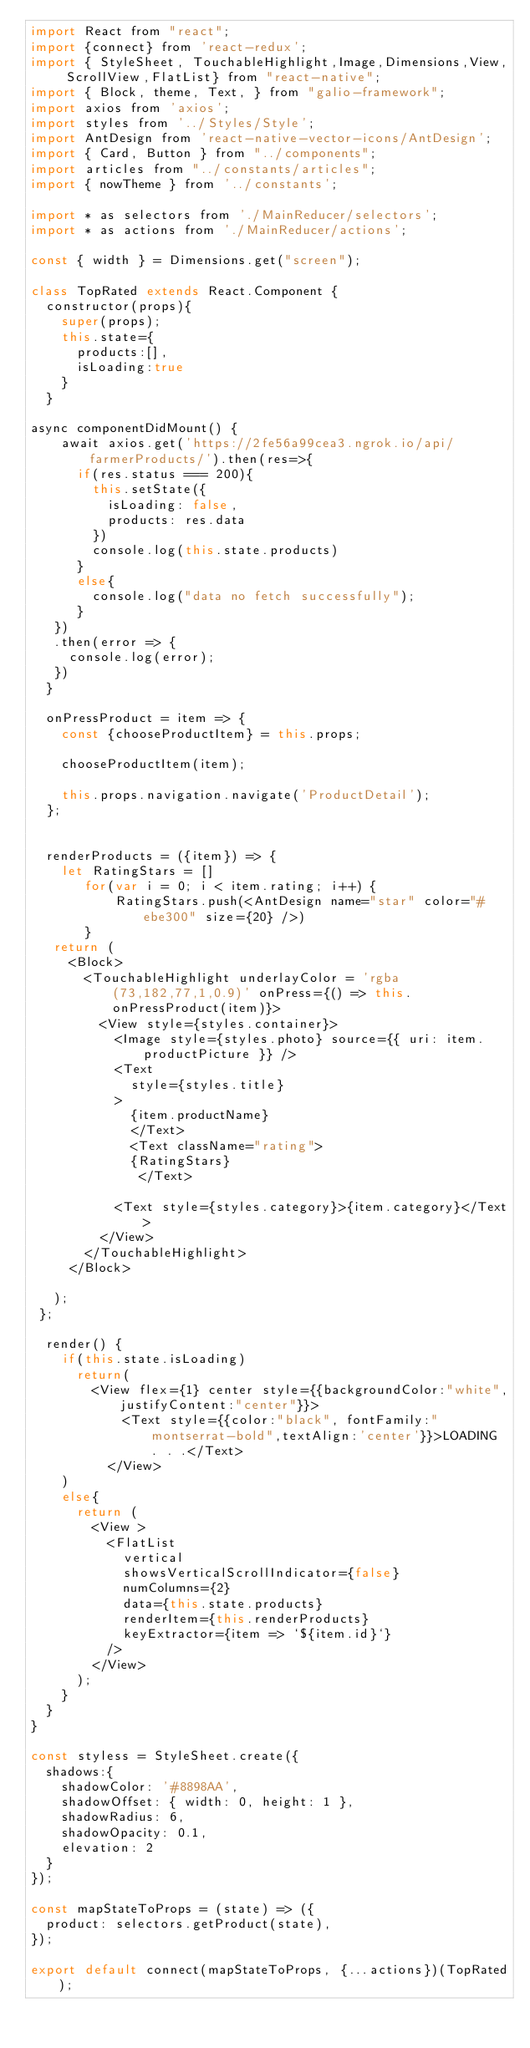<code> <loc_0><loc_0><loc_500><loc_500><_JavaScript_>import React from "react";
import {connect} from 'react-redux';
import { StyleSheet, TouchableHighlight,Image,Dimensions,View, ScrollView,FlatList} from "react-native";
import { Block, theme, Text, } from "galio-framework";
import axios from 'axios';
import styles from '../Styles/Style';
import AntDesign from 'react-native-vector-icons/AntDesign';
import { Card, Button } from "../components";
import articles from "../constants/articles";
import { nowTheme } from '../constants';

import * as selectors from './MainReducer/selectors';
import * as actions from './MainReducer/actions'; 

const { width } = Dimensions.get("screen");

class TopRated extends React.Component {
  constructor(props){
    super(props);
    this.state={
      products:[],
      isLoading:true
    }
  }

async componentDidMount() {    
    await axios.get('https://2fe56a99cea3.ngrok.io/api/farmerProducts/').then(res=>{
      if(res.status === 200){
        this.setState({
          isLoading: false,
          products: res.data 
        })
        console.log(this.state.products)
      }
      else{
        console.log("data no fetch successfully");
      }
   })
   .then(error => {
     console.log(error);
   })
  }
  
  onPressProduct = item => {
    const {chooseProductItem} = this.props;

    chooseProductItem(item);

    this.props.navigation.navigate('ProductDetail');
  };


  renderProducts = ({item}) => {
    let RatingStars = []
       for(var i = 0; i < item.rating; i++) {
           RatingStars.push(<AntDesign name="star" color="#ebe300" size={20} />)
       }
   return (
     <Block>
       <TouchableHighlight underlayColor = 'rgba(73,182,77,1,0.9)' onPress={() => this.onPressProduct(item)}>
         <View style={styles.container}>
           <Image style={styles.photo} source={{ uri: item.productPicture }} />
           <Text 
             style={styles.title}
           >
             {item.productName}
             </Text>
             <Text className="rating">
             {RatingStars}
              </Text>  
                
           <Text style={styles.category}>{item.category}</Text>
         </View>
       </TouchableHighlight>  
     </Block>      
     
   );
 };

  render() {
    if(this.state.isLoading) 
      return(
        <View flex={1} center style={{backgroundColor:"white",justifyContent:"center"}}>
            <Text style={{color:"black", fontFamily:"montserrat-bold",textAlign:'center'}}>LOADING . . .</Text>
          </View>
    )
    else{
      return (
        <View >
          <FlatList
            vertical
            showsVerticalScrollIndicator={false}
            numColumns={2}
            data={this.state.products}
            renderItem={this.renderProducts}
            keyExtractor={item => `${item.id}`}
          />
        </View>
      );
    }
  }
}

const styless = StyleSheet.create({
  shadows:{
    shadowColor: '#8898AA',
    shadowOffset: { width: 0, height: 1 },
    shadowRadius: 6,
    shadowOpacity: 0.1,
    elevation: 2
  }  
});

const mapStateToProps = (state) => ({
  product: selectors.getProduct(state),
});

export default connect(mapStateToProps, {...actions})(TopRated);

</code> 